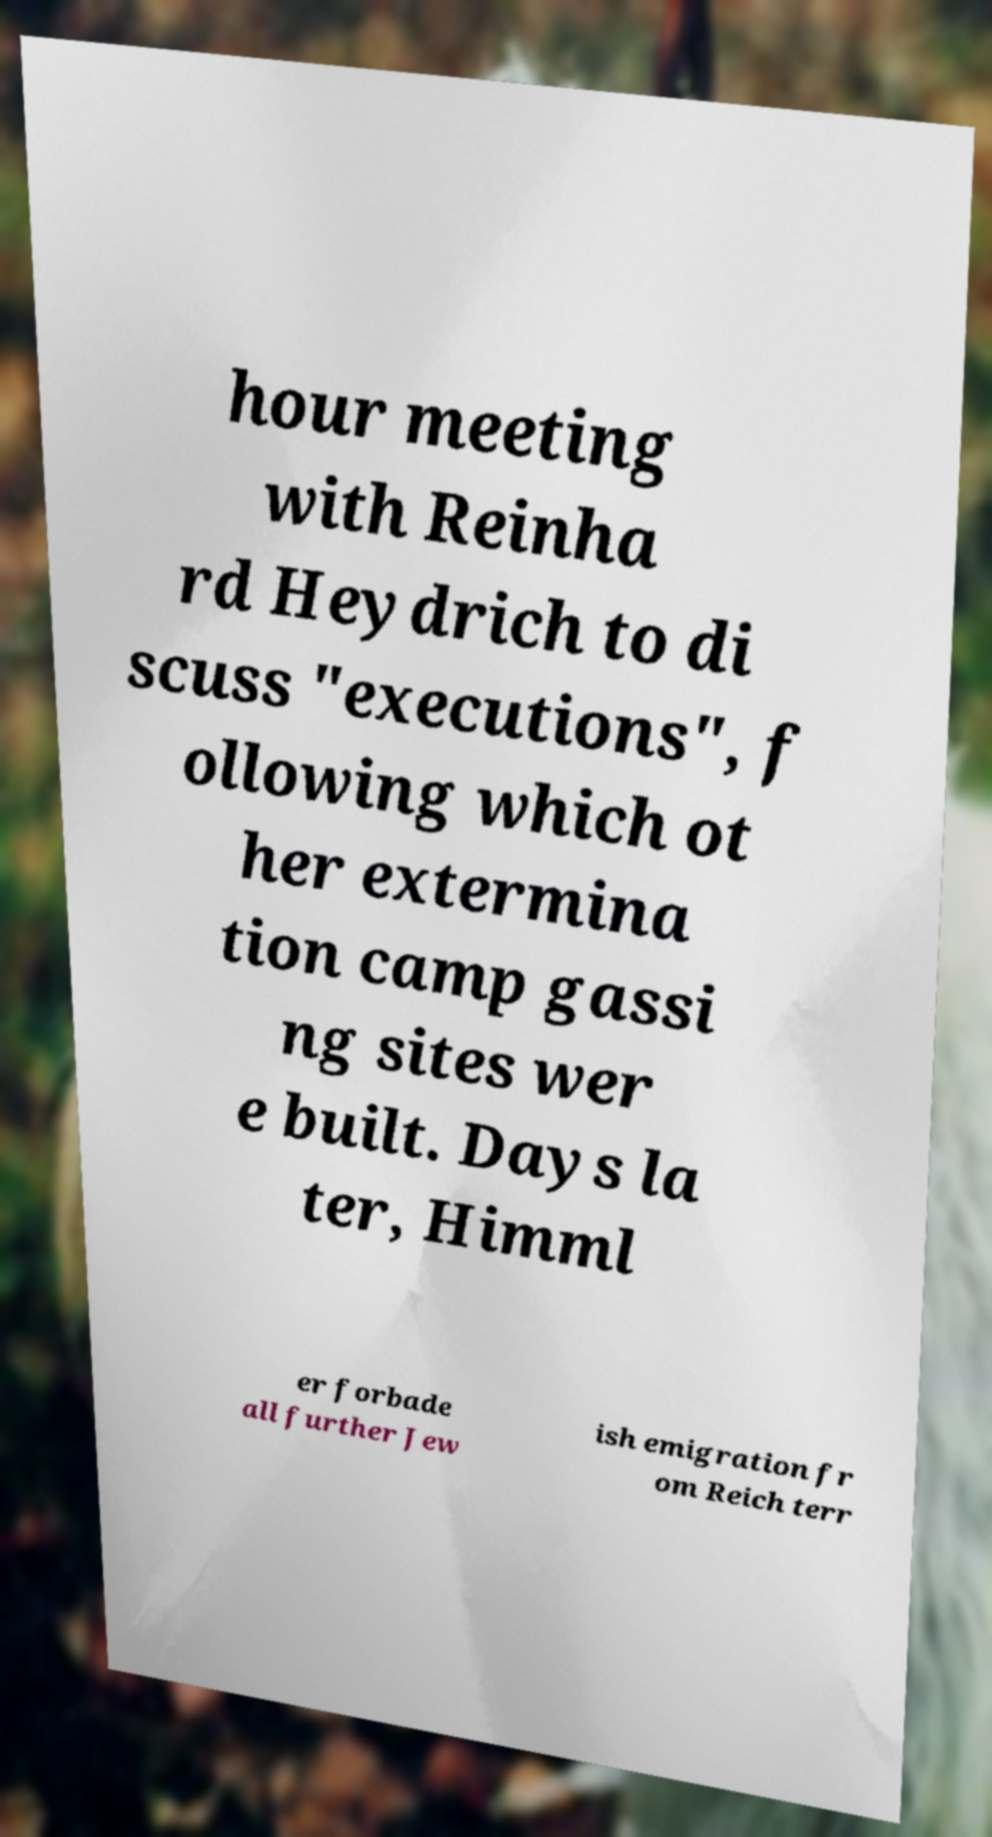Could you extract and type out the text from this image? hour meeting with Reinha rd Heydrich to di scuss "executions", f ollowing which ot her extermina tion camp gassi ng sites wer e built. Days la ter, Himml er forbade all further Jew ish emigration fr om Reich terr 